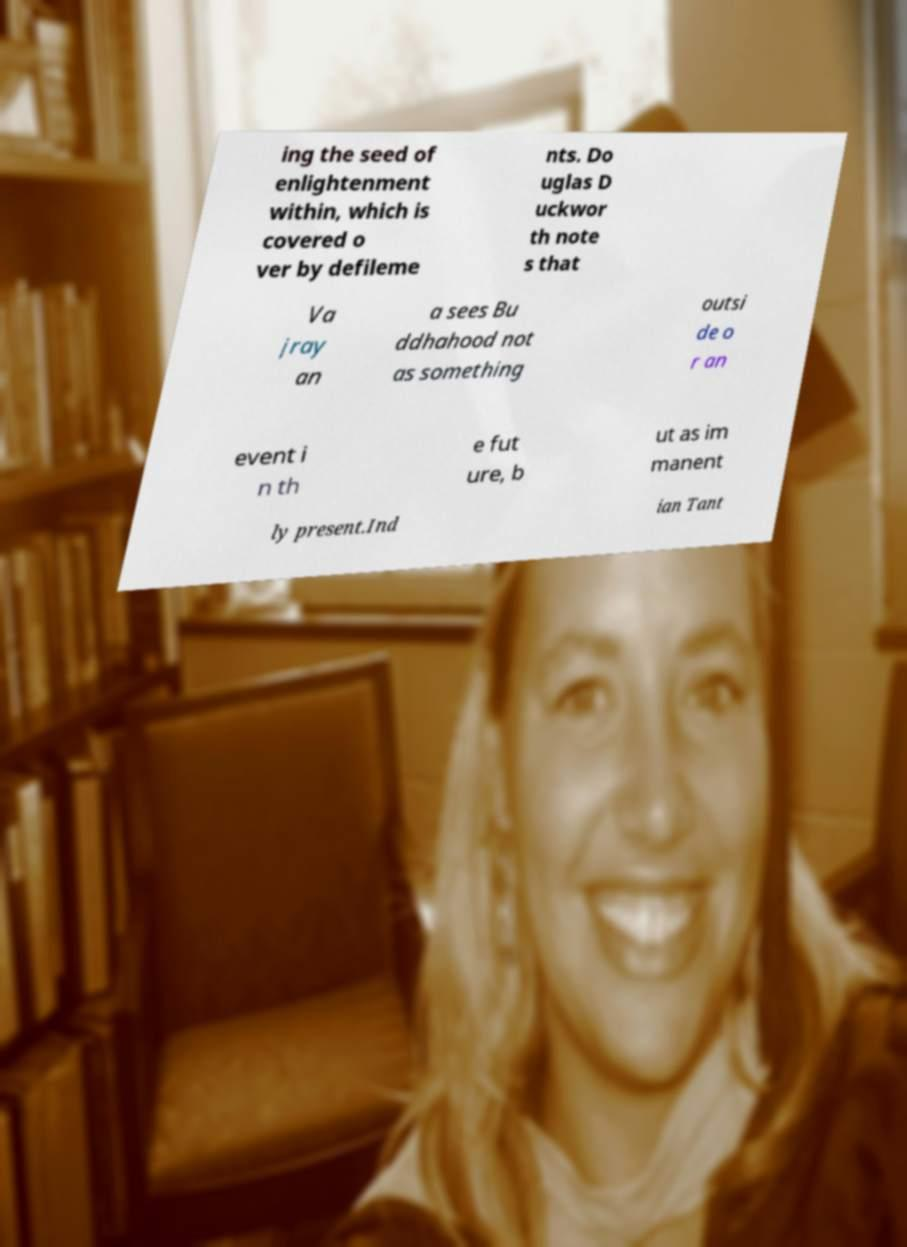Can you accurately transcribe the text from the provided image for me? ing the seed of enlightenment within, which is covered o ver by defileme nts. Do uglas D uckwor th note s that Va jray an a sees Bu ddhahood not as something outsi de o r an event i n th e fut ure, b ut as im manent ly present.Ind ian Tant 